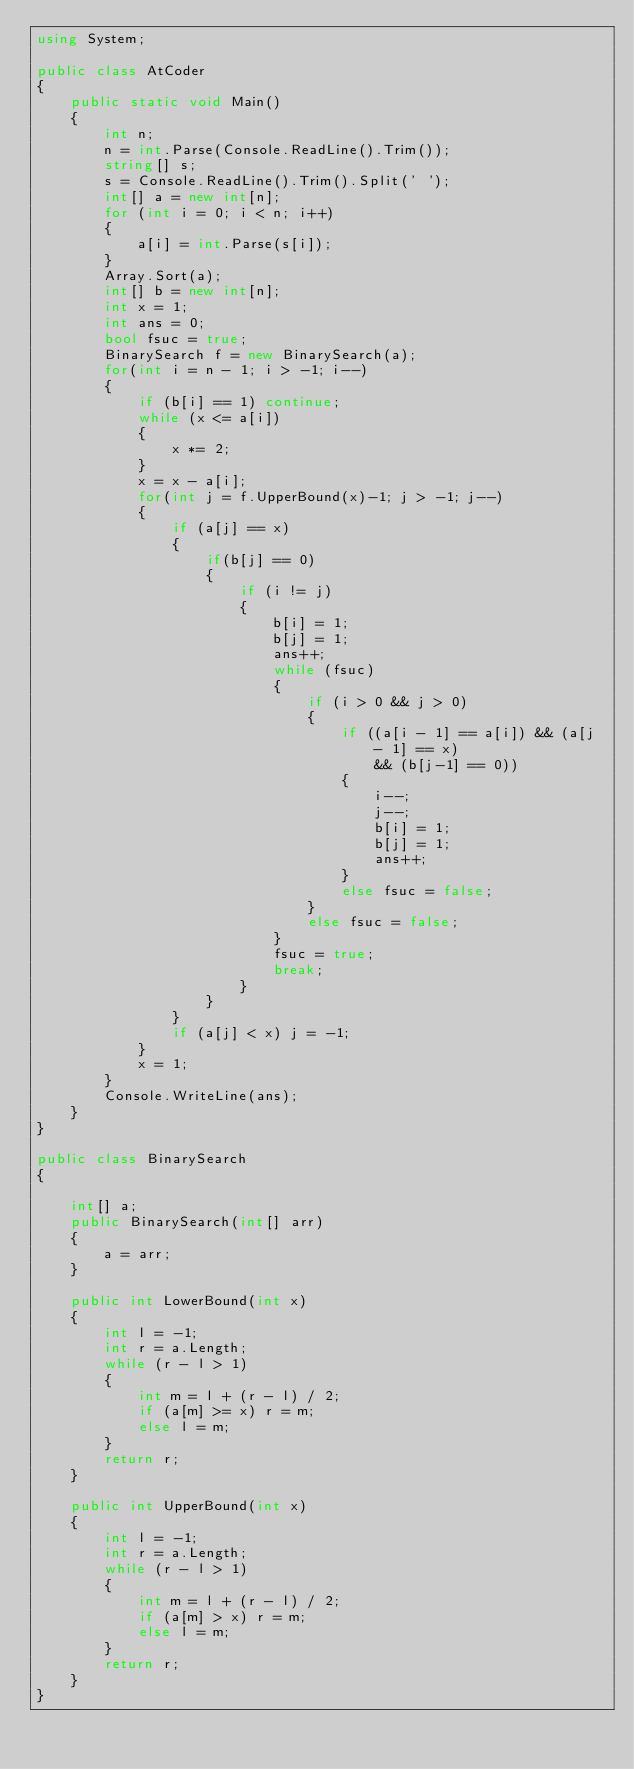Convert code to text. <code><loc_0><loc_0><loc_500><loc_500><_C#_>using System;

public class AtCoder
{
    public static void Main()
    {
        int n;
        n = int.Parse(Console.ReadLine().Trim());
        string[] s;
        s = Console.ReadLine().Trim().Split(' ');
        int[] a = new int[n];
        for (int i = 0; i < n; i++)
        {
            a[i] = int.Parse(s[i]);
        }
        Array.Sort(a);
        int[] b = new int[n];
        int x = 1;
        int ans = 0;
        bool fsuc = true;
        BinarySearch f = new BinarySearch(a);
        for(int i = n - 1; i > -1; i--)
        {
            if (b[i] == 1) continue;
            while (x <= a[i])
            {
                x *= 2;
            }
            x = x - a[i];
            for(int j = f.UpperBound(x)-1; j > -1; j--)
            {                
                if (a[j] == x)
                {
                    if(b[j] == 0)
                    {
                        if (i != j)
                        {
                            b[i] = 1;
                            b[j] = 1;
                            ans++;
                            while (fsuc)
                            {
                                if (i > 0 && j > 0)
                                {
                                    if ((a[i - 1] == a[i]) && (a[j - 1] == x)
                                        && (b[j-1] == 0))
                                    {                                        
                                        i--;
                                        j--;
                                        b[i] = 1;
                                        b[j] = 1;
                                        ans++;
                                    }
                                    else fsuc = false;
                                }
                                else fsuc = false;
                            }
                            fsuc = true;
                            break;
                        }                       
                    }
                }
                if (a[j] < x) j = -1;
            }
            x = 1;
        }
        Console.WriteLine(ans);
    }
}

public class BinarySearch
{

    int[] a;
    public BinarySearch(int[] arr)
    {
        a = arr;
    }

    public int LowerBound(int x)
    {
        int l = -1;
        int r = a.Length;
        while (r - l > 1)
        {
            int m = l + (r - l) / 2;
            if (a[m] >= x) r = m;
            else l = m;
        }
        return r;
    }

    public int UpperBound(int x)
    {
        int l = -1;
        int r = a.Length;
        while (r - l > 1)
        {
            int m = l + (r - l) / 2;
            if (a[m] > x) r = m;
            else l = m;
        }
        return r;
    }
}
</code> 